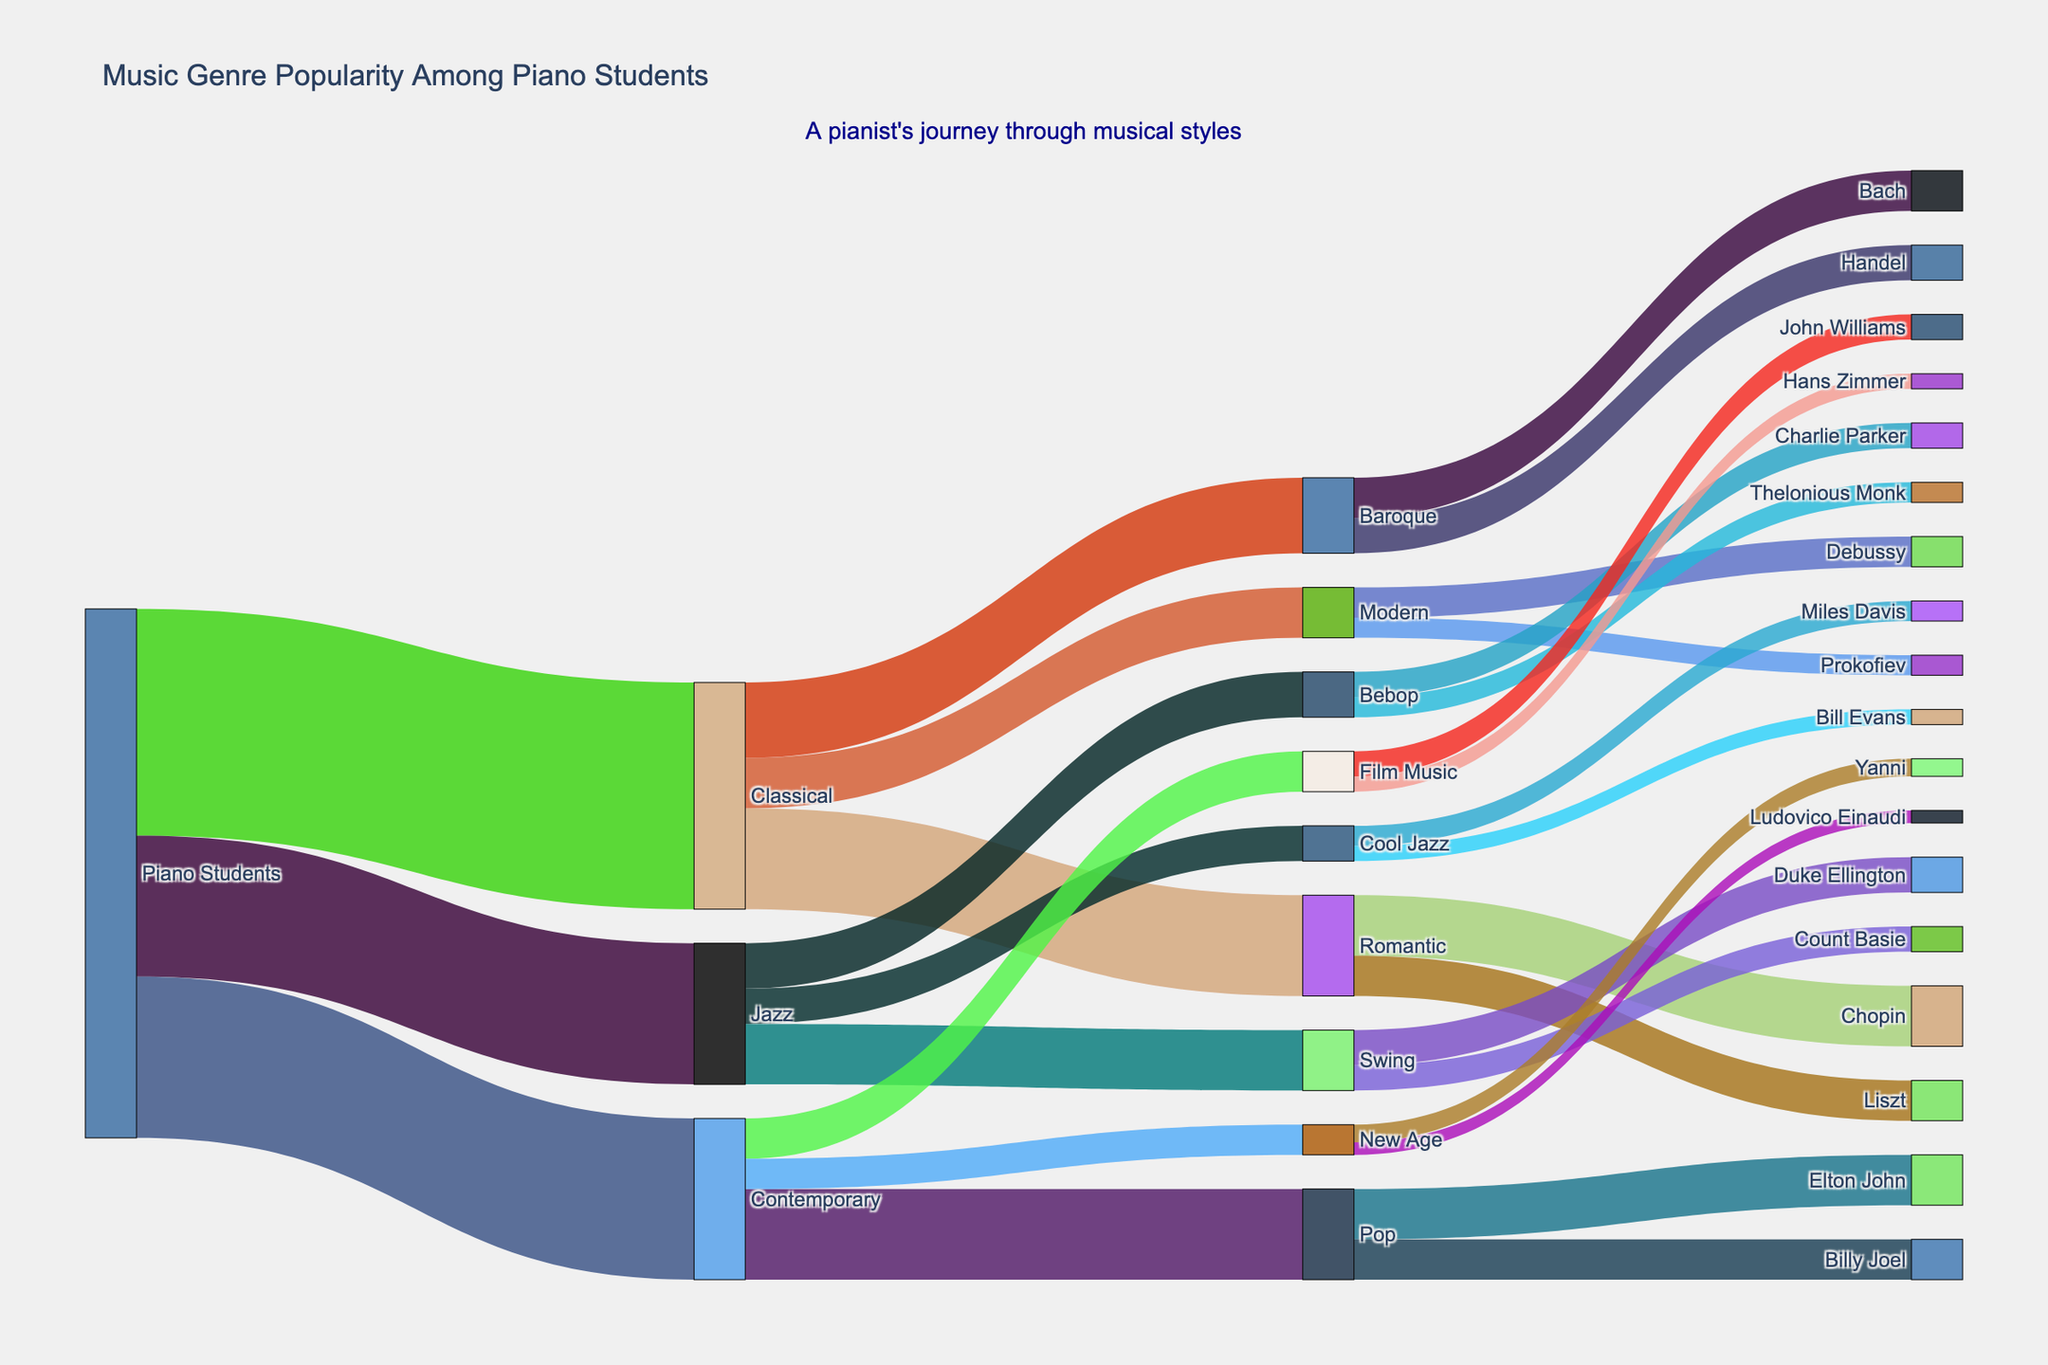What is the total number of piano students interested in different music genres? According to the Sankey diagram, the number of students interested in Classical is 450, Jazz is 280, and Contemporary is 320. Summing these numbers gives: 450 + 280 + 320 = 1050.
Answer: 1050 Which music genre among piano students has the highest popularity? By visually analyzing the width of the flows originating from "Piano Students", the Classical flow is the widest, corresponding to the highest popularity with 450 students.
Answer: Classical How many students are interested in Romantic music under the Classical genre? From the diagram, we follow the Classical branch and see that Romantic music has a value of 200 students.
Answer: 200 Compare the number of students interested in Baroque with those interested in Pop. Which group is larger and by how much? The Baroque branch under Classical shows 150 students (80 for Bach + 70 for Handel), while the Pop branch under Contemporary shows 180 students (100 for Elton John + 80 for Billy Joel). The difference is: 180 - 150 = 30.
Answer: Pop by 30 What is the sum of the number of students interested in all sub-genres of Jazz? Jazz sub-genres and their students are Swing (120), Bebop (90), and Cool Jazz (70). Summing these gives: 120 + 90 + 70 = 280.
Answer: 280 What percentage of piano students are interested in Contemporary music? There are 320 students interested in Contemporary out of a total of 1050 students. Calculating the percentage: (320 / 1050) * 100 = 30.48%.
Answer: 30.48% Identify the least popular sub-genre among all the music types and its number. Traversing through all sub-genre branches, New Age under Contemporary has the smallest numbers: Yanni (35) and Ludovico Einaudi (25), with Ludovico Einaudi having the smallest flow of 25 students.
Answer: Ludovico Einaudi (25) How does the number of students interested in Swing compare to those interested in Film Music? Swing has 120 students, while Film Music has 80. Comparing the two: 120 - 80 = 40. There are 40 more students interested in Swing.
Answer: Swing by 40 What is the combined number of students interested in Modern Classical and Bebop Jazz? Modern Classical sub-genres have Debussy (60) and Prokofiev (40), combined is 100. Bebop Jazz sub-genres have Charlie Parker (50) and Thelonious Monk (40), combined is 90. The total is: 100 + 90 = 190.
Answer: 190 Which sub-genre has the most students within Contemporary music and how many are there? Among Contemporary sub-genres, Pop (Elton John 100 + Billy Joel 80) has the most students, summing to 100 + 80 = 180 students.
Answer: Pop (180) 